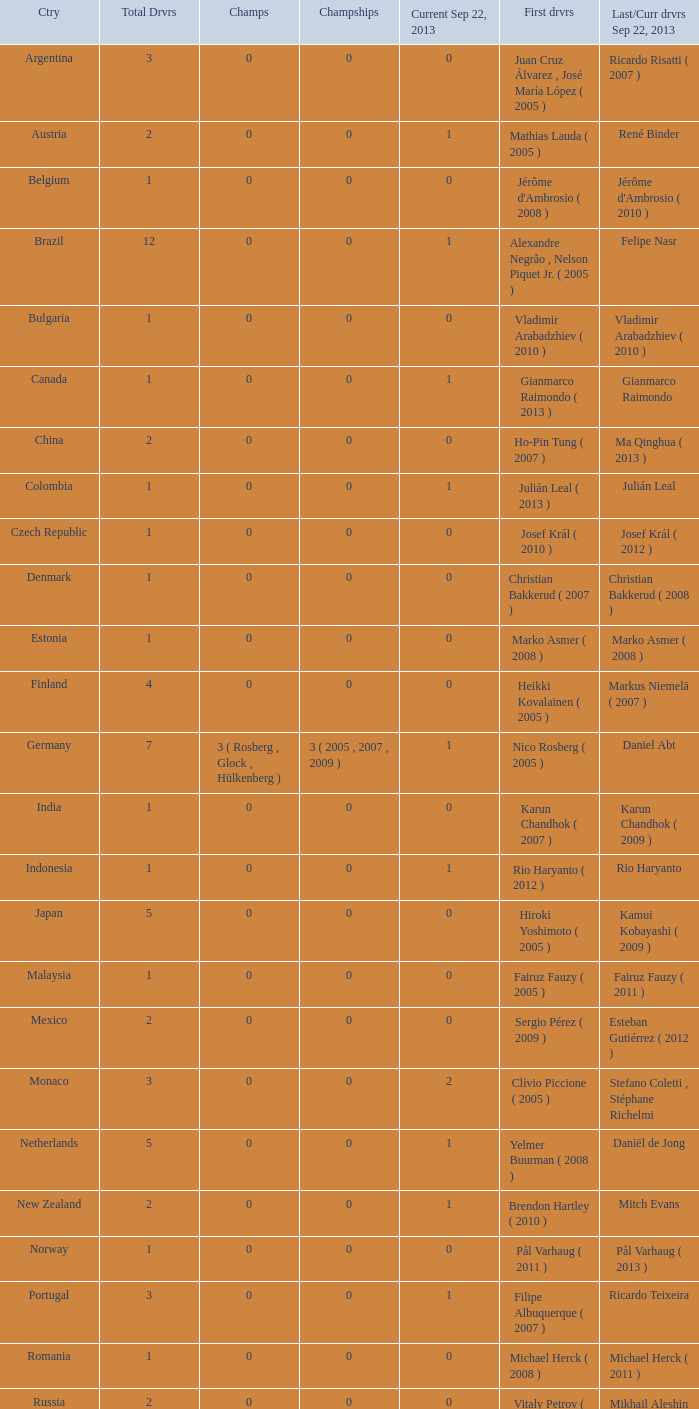How many champions were there when the last driver for September 22, 2013 was vladimir arabadzhiev ( 2010 )? 0.0. 